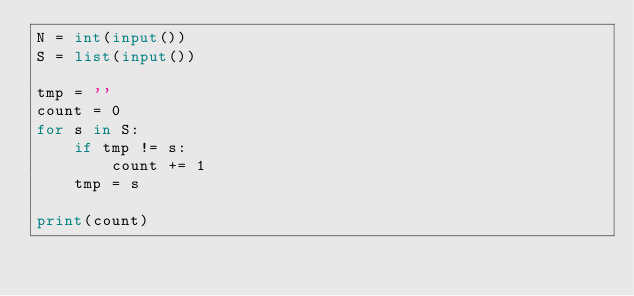Convert code to text. <code><loc_0><loc_0><loc_500><loc_500><_Python_>N = int(input())
S = list(input())

tmp = ''
count = 0
for s in S:
    if tmp != s:
        count += 1
    tmp = s

print(count)</code> 